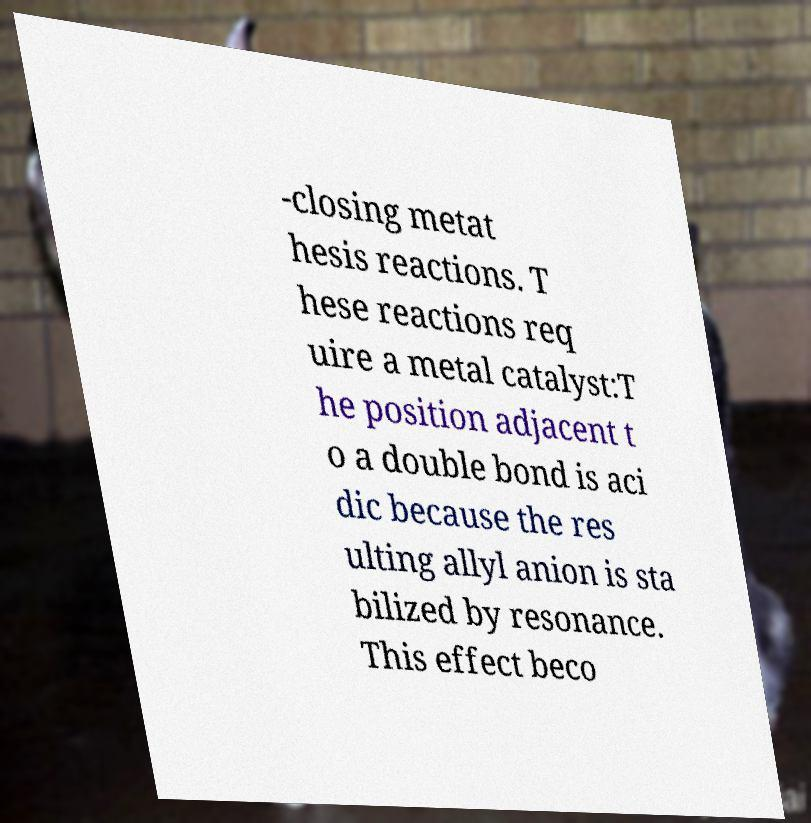There's text embedded in this image that I need extracted. Can you transcribe it verbatim? -closing metat hesis reactions. T hese reactions req uire a metal catalyst:T he position adjacent t o a double bond is aci dic because the res ulting allyl anion is sta bilized by resonance. This effect beco 